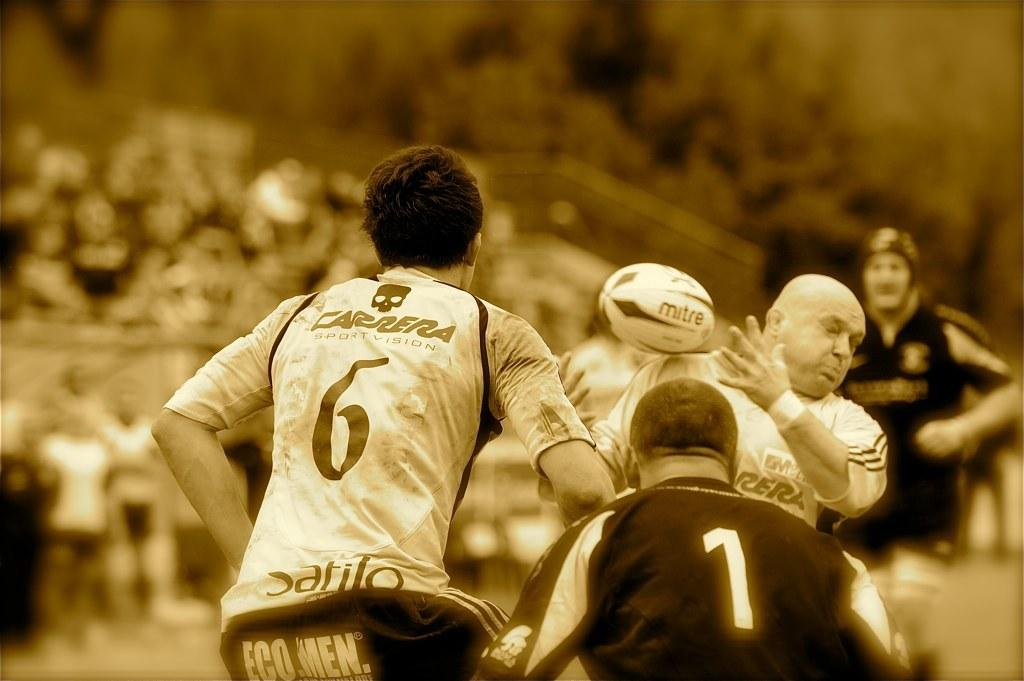<image>
Give a short and clear explanation of the subsequent image. some sports people playing a game in jerseys such as 6 and 1 